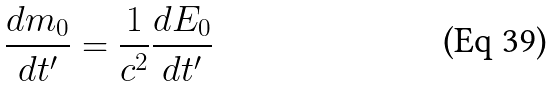Convert formula to latex. <formula><loc_0><loc_0><loc_500><loc_500>\frac { d m _ { 0 } } { d t ^ { \prime } } = \frac { 1 } { c ^ { 2 } } \frac { d E _ { 0 } } { d t ^ { \prime } }</formula> 